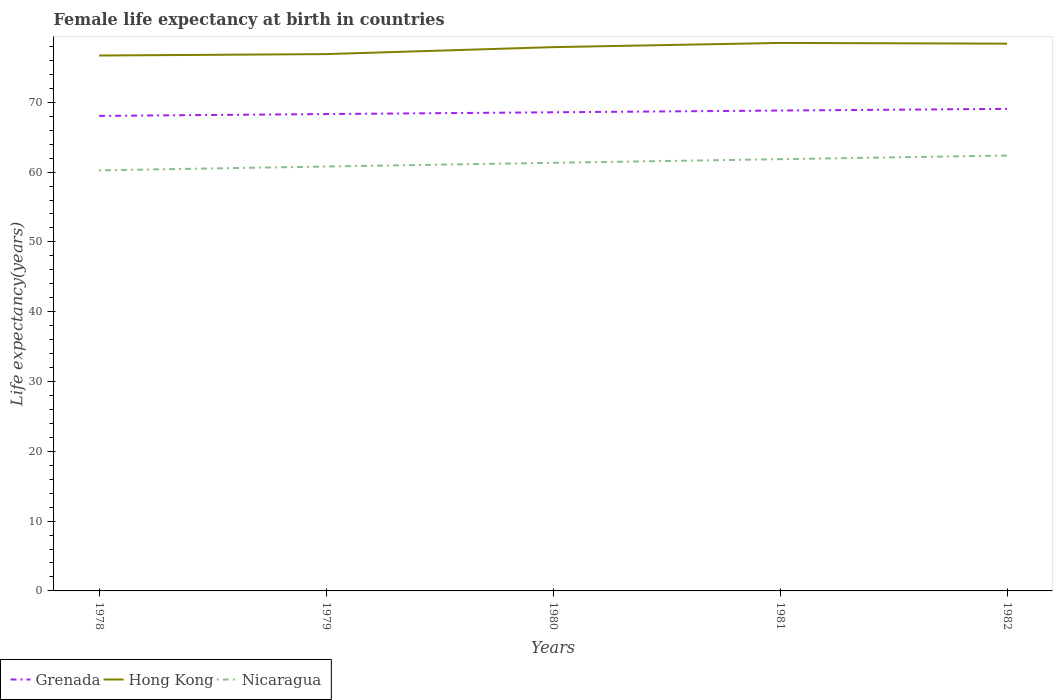Across all years, what is the maximum female life expectancy at birth in Grenada?
Your response must be concise. 68.05. In which year was the female life expectancy at birth in Hong Kong maximum?
Make the answer very short. 1978. What is the total female life expectancy at birth in Hong Kong in the graph?
Make the answer very short. -1.6. What is the difference between the highest and the second highest female life expectancy at birth in Hong Kong?
Make the answer very short. 1.8. What is the difference between the highest and the lowest female life expectancy at birth in Hong Kong?
Make the answer very short. 3. Is the female life expectancy at birth in Grenada strictly greater than the female life expectancy at birth in Hong Kong over the years?
Offer a terse response. Yes. How many years are there in the graph?
Make the answer very short. 5. Are the values on the major ticks of Y-axis written in scientific E-notation?
Give a very brief answer. No. Where does the legend appear in the graph?
Provide a short and direct response. Bottom left. How many legend labels are there?
Make the answer very short. 3. What is the title of the graph?
Offer a terse response. Female life expectancy at birth in countries. What is the label or title of the Y-axis?
Offer a very short reply. Life expectancy(years). What is the Life expectancy(years) in Grenada in 1978?
Provide a succinct answer. 68.05. What is the Life expectancy(years) in Hong Kong in 1978?
Your response must be concise. 76.7. What is the Life expectancy(years) of Nicaragua in 1978?
Ensure brevity in your answer.  60.25. What is the Life expectancy(years) of Grenada in 1979?
Your answer should be very brief. 68.31. What is the Life expectancy(years) in Hong Kong in 1979?
Keep it short and to the point. 76.9. What is the Life expectancy(years) in Nicaragua in 1979?
Your answer should be compact. 60.8. What is the Life expectancy(years) in Grenada in 1980?
Provide a short and direct response. 68.57. What is the Life expectancy(years) in Hong Kong in 1980?
Your answer should be compact. 77.9. What is the Life expectancy(years) of Nicaragua in 1980?
Make the answer very short. 61.33. What is the Life expectancy(years) in Grenada in 1981?
Give a very brief answer. 68.82. What is the Life expectancy(years) in Hong Kong in 1981?
Your answer should be very brief. 78.5. What is the Life expectancy(years) of Nicaragua in 1981?
Provide a succinct answer. 61.85. What is the Life expectancy(years) in Grenada in 1982?
Your answer should be compact. 69.06. What is the Life expectancy(years) of Hong Kong in 1982?
Offer a very short reply. 78.4. What is the Life expectancy(years) of Nicaragua in 1982?
Keep it short and to the point. 62.37. Across all years, what is the maximum Life expectancy(years) of Grenada?
Your answer should be very brief. 69.06. Across all years, what is the maximum Life expectancy(years) of Hong Kong?
Provide a short and direct response. 78.5. Across all years, what is the maximum Life expectancy(years) of Nicaragua?
Ensure brevity in your answer.  62.37. Across all years, what is the minimum Life expectancy(years) in Grenada?
Give a very brief answer. 68.05. Across all years, what is the minimum Life expectancy(years) in Hong Kong?
Ensure brevity in your answer.  76.7. Across all years, what is the minimum Life expectancy(years) of Nicaragua?
Provide a short and direct response. 60.25. What is the total Life expectancy(years) in Grenada in the graph?
Your answer should be very brief. 342.81. What is the total Life expectancy(years) in Hong Kong in the graph?
Make the answer very short. 388.4. What is the total Life expectancy(years) in Nicaragua in the graph?
Ensure brevity in your answer.  306.6. What is the difference between the Life expectancy(years) in Grenada in 1978 and that in 1979?
Make the answer very short. -0.26. What is the difference between the Life expectancy(years) of Hong Kong in 1978 and that in 1979?
Provide a succinct answer. -0.2. What is the difference between the Life expectancy(years) of Nicaragua in 1978 and that in 1979?
Make the answer very short. -0.55. What is the difference between the Life expectancy(years) of Grenada in 1978 and that in 1980?
Make the answer very short. -0.52. What is the difference between the Life expectancy(years) in Hong Kong in 1978 and that in 1980?
Your answer should be very brief. -1.2. What is the difference between the Life expectancy(years) of Nicaragua in 1978 and that in 1980?
Your answer should be compact. -1.08. What is the difference between the Life expectancy(years) of Grenada in 1978 and that in 1981?
Your response must be concise. -0.77. What is the difference between the Life expectancy(years) in Grenada in 1978 and that in 1982?
Keep it short and to the point. -1.01. What is the difference between the Life expectancy(years) of Nicaragua in 1978 and that in 1982?
Your answer should be compact. -2.12. What is the difference between the Life expectancy(years) of Grenada in 1979 and that in 1980?
Provide a succinct answer. -0.26. What is the difference between the Life expectancy(years) of Nicaragua in 1979 and that in 1980?
Your answer should be compact. -0.53. What is the difference between the Life expectancy(years) in Grenada in 1979 and that in 1981?
Provide a succinct answer. -0.5. What is the difference between the Life expectancy(years) of Nicaragua in 1979 and that in 1981?
Give a very brief answer. -1.05. What is the difference between the Life expectancy(years) in Grenada in 1979 and that in 1982?
Make the answer very short. -0.74. What is the difference between the Life expectancy(years) of Hong Kong in 1979 and that in 1982?
Your answer should be compact. -1.5. What is the difference between the Life expectancy(years) of Nicaragua in 1979 and that in 1982?
Keep it short and to the point. -1.57. What is the difference between the Life expectancy(years) in Grenada in 1980 and that in 1981?
Provide a succinct answer. -0.25. What is the difference between the Life expectancy(years) of Hong Kong in 1980 and that in 1981?
Keep it short and to the point. -0.6. What is the difference between the Life expectancy(years) in Nicaragua in 1980 and that in 1981?
Your answer should be very brief. -0.52. What is the difference between the Life expectancy(years) of Grenada in 1980 and that in 1982?
Offer a terse response. -0.49. What is the difference between the Life expectancy(years) of Nicaragua in 1980 and that in 1982?
Offer a very short reply. -1.04. What is the difference between the Life expectancy(years) in Grenada in 1981 and that in 1982?
Your answer should be compact. -0.24. What is the difference between the Life expectancy(years) of Hong Kong in 1981 and that in 1982?
Keep it short and to the point. 0.1. What is the difference between the Life expectancy(years) in Nicaragua in 1981 and that in 1982?
Provide a succinct answer. -0.52. What is the difference between the Life expectancy(years) of Grenada in 1978 and the Life expectancy(years) of Hong Kong in 1979?
Give a very brief answer. -8.85. What is the difference between the Life expectancy(years) of Grenada in 1978 and the Life expectancy(years) of Nicaragua in 1979?
Your answer should be very brief. 7.25. What is the difference between the Life expectancy(years) of Hong Kong in 1978 and the Life expectancy(years) of Nicaragua in 1979?
Your answer should be compact. 15.9. What is the difference between the Life expectancy(years) of Grenada in 1978 and the Life expectancy(years) of Hong Kong in 1980?
Give a very brief answer. -9.85. What is the difference between the Life expectancy(years) in Grenada in 1978 and the Life expectancy(years) in Nicaragua in 1980?
Keep it short and to the point. 6.72. What is the difference between the Life expectancy(years) in Hong Kong in 1978 and the Life expectancy(years) in Nicaragua in 1980?
Provide a succinct answer. 15.37. What is the difference between the Life expectancy(years) of Grenada in 1978 and the Life expectancy(years) of Hong Kong in 1981?
Keep it short and to the point. -10.45. What is the difference between the Life expectancy(years) in Hong Kong in 1978 and the Life expectancy(years) in Nicaragua in 1981?
Offer a very short reply. 14.85. What is the difference between the Life expectancy(years) in Grenada in 1978 and the Life expectancy(years) in Hong Kong in 1982?
Your response must be concise. -10.35. What is the difference between the Life expectancy(years) in Grenada in 1978 and the Life expectancy(years) in Nicaragua in 1982?
Your answer should be compact. 5.68. What is the difference between the Life expectancy(years) of Hong Kong in 1978 and the Life expectancy(years) of Nicaragua in 1982?
Offer a very short reply. 14.33. What is the difference between the Life expectancy(years) in Grenada in 1979 and the Life expectancy(years) in Hong Kong in 1980?
Ensure brevity in your answer.  -9.59. What is the difference between the Life expectancy(years) in Grenada in 1979 and the Life expectancy(years) in Nicaragua in 1980?
Provide a succinct answer. 6.99. What is the difference between the Life expectancy(years) of Hong Kong in 1979 and the Life expectancy(years) of Nicaragua in 1980?
Give a very brief answer. 15.57. What is the difference between the Life expectancy(years) of Grenada in 1979 and the Life expectancy(years) of Hong Kong in 1981?
Offer a very short reply. -10.19. What is the difference between the Life expectancy(years) in Grenada in 1979 and the Life expectancy(years) in Nicaragua in 1981?
Make the answer very short. 6.46. What is the difference between the Life expectancy(years) in Hong Kong in 1979 and the Life expectancy(years) in Nicaragua in 1981?
Provide a short and direct response. 15.05. What is the difference between the Life expectancy(years) of Grenada in 1979 and the Life expectancy(years) of Hong Kong in 1982?
Your answer should be compact. -10.09. What is the difference between the Life expectancy(years) of Grenada in 1979 and the Life expectancy(years) of Nicaragua in 1982?
Give a very brief answer. 5.94. What is the difference between the Life expectancy(years) in Hong Kong in 1979 and the Life expectancy(years) in Nicaragua in 1982?
Offer a terse response. 14.53. What is the difference between the Life expectancy(years) in Grenada in 1980 and the Life expectancy(years) in Hong Kong in 1981?
Offer a very short reply. -9.93. What is the difference between the Life expectancy(years) in Grenada in 1980 and the Life expectancy(years) in Nicaragua in 1981?
Keep it short and to the point. 6.72. What is the difference between the Life expectancy(years) in Hong Kong in 1980 and the Life expectancy(years) in Nicaragua in 1981?
Your response must be concise. 16.05. What is the difference between the Life expectancy(years) in Grenada in 1980 and the Life expectancy(years) in Hong Kong in 1982?
Provide a short and direct response. -9.83. What is the difference between the Life expectancy(years) in Grenada in 1980 and the Life expectancy(years) in Nicaragua in 1982?
Make the answer very short. 6.2. What is the difference between the Life expectancy(years) in Hong Kong in 1980 and the Life expectancy(years) in Nicaragua in 1982?
Ensure brevity in your answer.  15.53. What is the difference between the Life expectancy(years) in Grenada in 1981 and the Life expectancy(years) in Hong Kong in 1982?
Make the answer very short. -9.58. What is the difference between the Life expectancy(years) in Grenada in 1981 and the Life expectancy(years) in Nicaragua in 1982?
Offer a terse response. 6.44. What is the difference between the Life expectancy(years) in Hong Kong in 1981 and the Life expectancy(years) in Nicaragua in 1982?
Give a very brief answer. 16.13. What is the average Life expectancy(years) of Grenada per year?
Keep it short and to the point. 68.56. What is the average Life expectancy(years) of Hong Kong per year?
Make the answer very short. 77.68. What is the average Life expectancy(years) of Nicaragua per year?
Offer a very short reply. 61.32. In the year 1978, what is the difference between the Life expectancy(years) of Grenada and Life expectancy(years) of Hong Kong?
Give a very brief answer. -8.65. In the year 1978, what is the difference between the Life expectancy(years) of Hong Kong and Life expectancy(years) of Nicaragua?
Keep it short and to the point. 16.45. In the year 1979, what is the difference between the Life expectancy(years) of Grenada and Life expectancy(years) of Hong Kong?
Ensure brevity in your answer.  -8.59. In the year 1979, what is the difference between the Life expectancy(years) of Grenada and Life expectancy(years) of Nicaragua?
Make the answer very short. 7.52. In the year 1979, what is the difference between the Life expectancy(years) in Hong Kong and Life expectancy(years) in Nicaragua?
Your answer should be compact. 16.1. In the year 1980, what is the difference between the Life expectancy(years) of Grenada and Life expectancy(years) of Hong Kong?
Your answer should be very brief. -9.33. In the year 1980, what is the difference between the Life expectancy(years) in Grenada and Life expectancy(years) in Nicaragua?
Make the answer very short. 7.24. In the year 1980, what is the difference between the Life expectancy(years) in Hong Kong and Life expectancy(years) in Nicaragua?
Provide a succinct answer. 16.57. In the year 1981, what is the difference between the Life expectancy(years) in Grenada and Life expectancy(years) in Hong Kong?
Provide a short and direct response. -9.68. In the year 1981, what is the difference between the Life expectancy(years) in Grenada and Life expectancy(years) in Nicaragua?
Make the answer very short. 6.97. In the year 1981, what is the difference between the Life expectancy(years) in Hong Kong and Life expectancy(years) in Nicaragua?
Offer a very short reply. 16.65. In the year 1982, what is the difference between the Life expectancy(years) in Grenada and Life expectancy(years) in Hong Kong?
Your answer should be very brief. -9.34. In the year 1982, what is the difference between the Life expectancy(years) of Grenada and Life expectancy(years) of Nicaragua?
Make the answer very short. 6.69. In the year 1982, what is the difference between the Life expectancy(years) in Hong Kong and Life expectancy(years) in Nicaragua?
Your answer should be compact. 16.03. What is the ratio of the Life expectancy(years) in Grenada in 1978 to that in 1980?
Offer a terse response. 0.99. What is the ratio of the Life expectancy(years) in Hong Kong in 1978 to that in 1980?
Your answer should be compact. 0.98. What is the ratio of the Life expectancy(years) in Nicaragua in 1978 to that in 1980?
Provide a short and direct response. 0.98. What is the ratio of the Life expectancy(years) in Grenada in 1978 to that in 1981?
Provide a succinct answer. 0.99. What is the ratio of the Life expectancy(years) of Hong Kong in 1978 to that in 1981?
Ensure brevity in your answer.  0.98. What is the ratio of the Life expectancy(years) in Nicaragua in 1978 to that in 1981?
Provide a succinct answer. 0.97. What is the ratio of the Life expectancy(years) of Grenada in 1978 to that in 1982?
Make the answer very short. 0.99. What is the ratio of the Life expectancy(years) of Hong Kong in 1978 to that in 1982?
Give a very brief answer. 0.98. What is the ratio of the Life expectancy(years) in Nicaragua in 1978 to that in 1982?
Offer a very short reply. 0.97. What is the ratio of the Life expectancy(years) of Hong Kong in 1979 to that in 1980?
Provide a succinct answer. 0.99. What is the ratio of the Life expectancy(years) of Nicaragua in 1979 to that in 1980?
Provide a succinct answer. 0.99. What is the ratio of the Life expectancy(years) of Hong Kong in 1979 to that in 1981?
Provide a succinct answer. 0.98. What is the ratio of the Life expectancy(years) of Grenada in 1979 to that in 1982?
Offer a terse response. 0.99. What is the ratio of the Life expectancy(years) in Hong Kong in 1979 to that in 1982?
Your answer should be compact. 0.98. What is the ratio of the Life expectancy(years) in Nicaragua in 1979 to that in 1982?
Offer a very short reply. 0.97. What is the ratio of the Life expectancy(years) of Grenada in 1980 to that in 1981?
Make the answer very short. 1. What is the ratio of the Life expectancy(years) in Grenada in 1980 to that in 1982?
Give a very brief answer. 0.99. What is the ratio of the Life expectancy(years) of Hong Kong in 1980 to that in 1982?
Offer a very short reply. 0.99. What is the ratio of the Life expectancy(years) in Nicaragua in 1980 to that in 1982?
Your answer should be compact. 0.98. What is the ratio of the Life expectancy(years) of Hong Kong in 1981 to that in 1982?
Offer a very short reply. 1. What is the difference between the highest and the second highest Life expectancy(years) in Grenada?
Give a very brief answer. 0.24. What is the difference between the highest and the second highest Life expectancy(years) of Nicaragua?
Offer a very short reply. 0.52. What is the difference between the highest and the lowest Life expectancy(years) in Hong Kong?
Ensure brevity in your answer.  1.8. What is the difference between the highest and the lowest Life expectancy(years) of Nicaragua?
Provide a short and direct response. 2.12. 